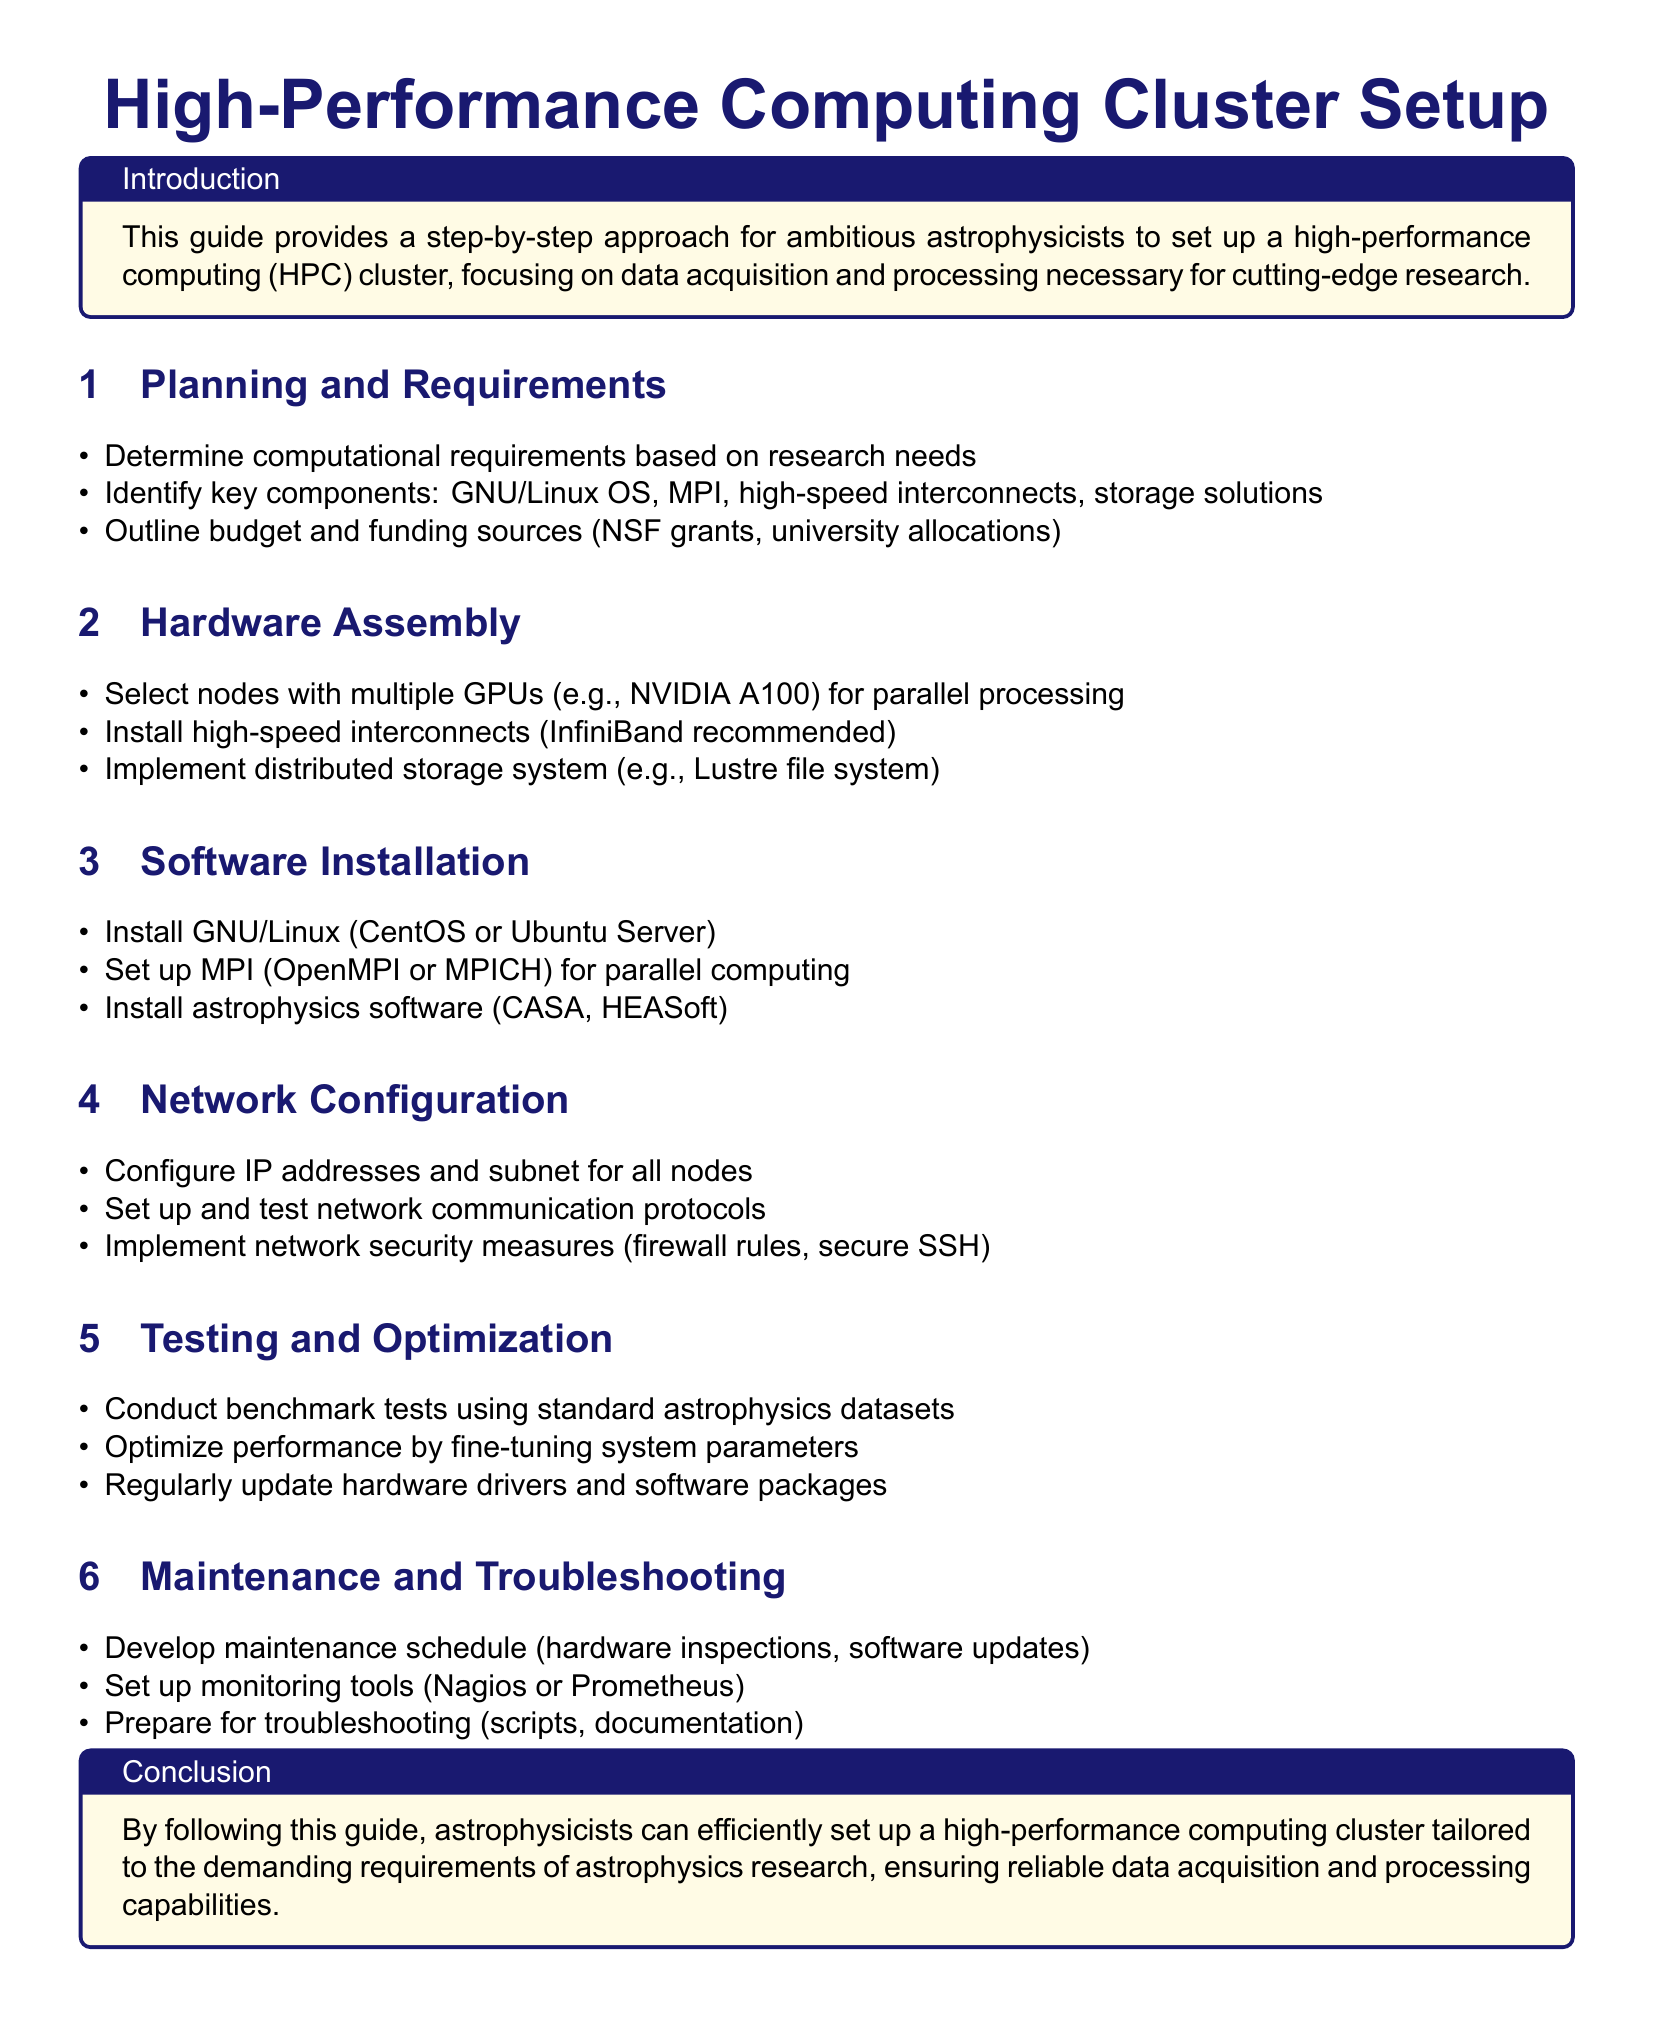What is the primary focus of the guide? The guide focuses on setting up a high-performance computing cluster for astrophysics research.
Answer: HPC cluster for astrophysics research What operating systems are suggested for installation? Suggested operating systems for installation include CentOS or Ubuntu Server.
Answer: CentOS or Ubuntu Server What high-speed interconnect is recommended? The guide recommends InfiniBand for high-speed interconnects.
Answer: InfiniBand Name one software that should be installed for astrophysics. One software that should be installed is CASA.
Answer: CASA How many main sections are in the document? The document contains six main sections detailing different aspects of the setup process.
Answer: Six What needs to be configured for all nodes during network configuration? The IP addresses and subnet need to be configured for all nodes.
Answer: IP addresses and subnet Which monitoring tool is mentioned for maintenance? Nagios is mentioned as a monitoring tool for maintenance.
Answer: Nagios What is the purpose of benchmark tests? The purpose of benchmark tests is to assess system performance using standard astrophysics datasets.
Answer: Assess system performance What does the conclusion emphasize? The conclusion emphasizes the efficient setup of a high-performance computing cluster.
Answer: Efficient setup of an HPC cluster 